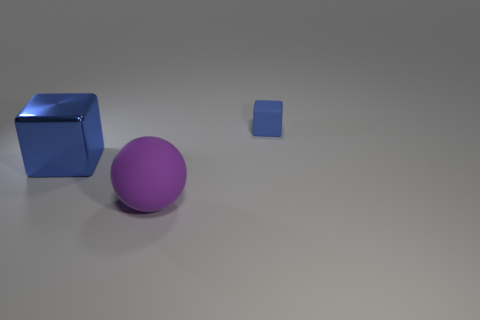Add 1 large balls. How many objects exist? 4 Subtract all spheres. How many objects are left? 2 Subtract all tiny objects. Subtract all tiny green cylinders. How many objects are left? 2 Add 3 large blocks. How many large blocks are left? 4 Add 2 big purple spheres. How many big purple spheres exist? 3 Subtract 0 gray cubes. How many objects are left? 3 